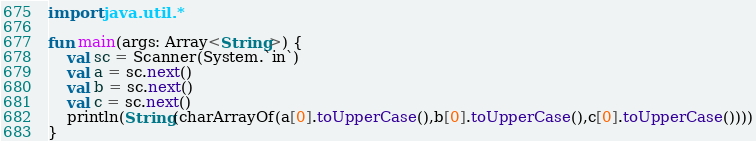<code> <loc_0><loc_0><loc_500><loc_500><_Kotlin_>import java.util.*

fun main(args: Array<String>) {
    val sc = Scanner(System.`in`)
    val a = sc.next()
    val b = sc.next()
    val c = sc.next()
    println(String(charArrayOf(a[0].toUpperCase(),b[0].toUpperCase(),c[0].toUpperCase())))
}</code> 